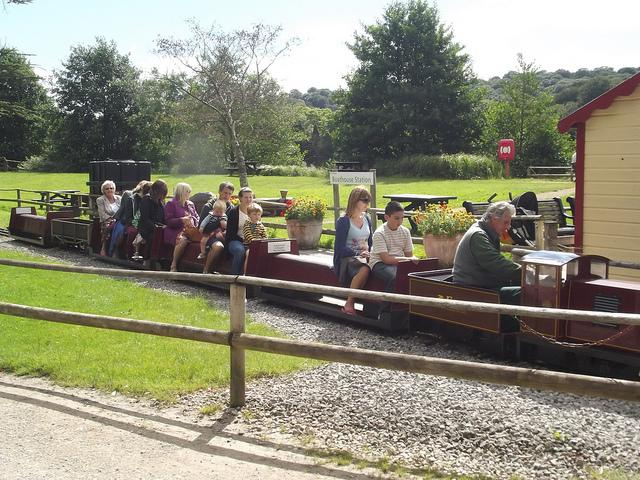What type people ride on this train? kids 